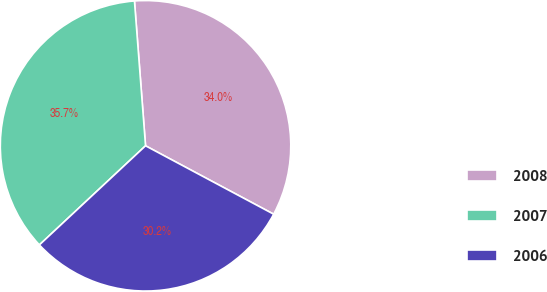Convert chart. <chart><loc_0><loc_0><loc_500><loc_500><pie_chart><fcel>2008<fcel>2007<fcel>2006<nl><fcel>34.02%<fcel>35.74%<fcel>30.24%<nl></chart> 